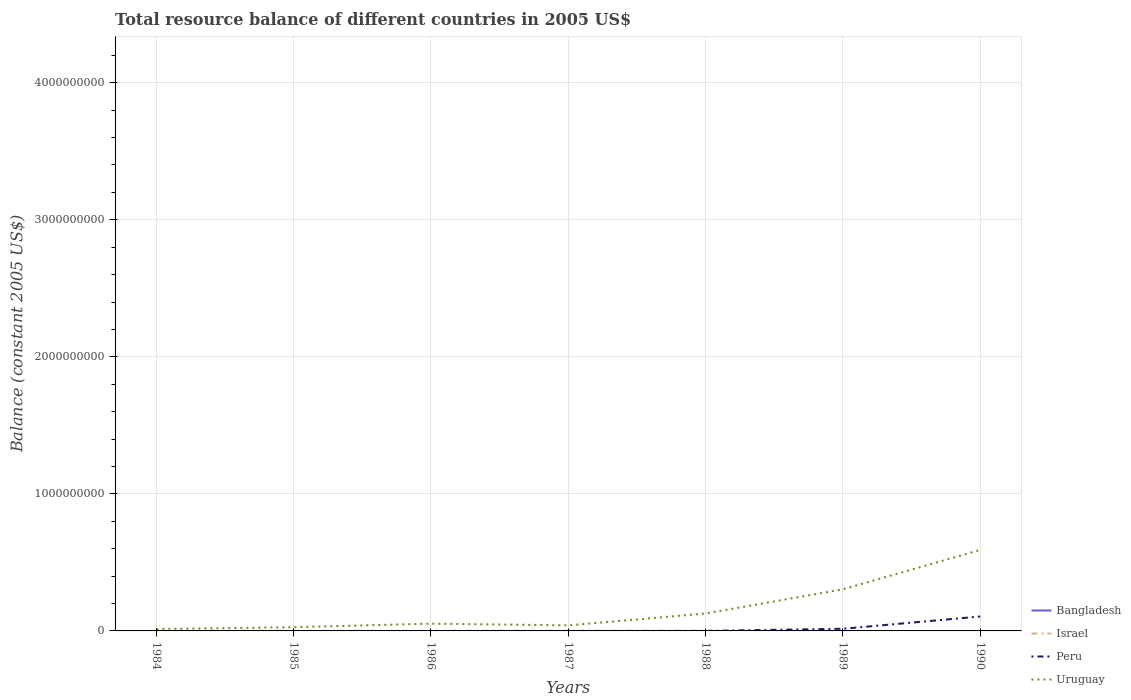Does the line corresponding to Peru intersect with the line corresponding to Israel?
Provide a succinct answer. No. Across all years, what is the maximum total resource balance in Uruguay?
Make the answer very short. 1.41e+07. What is the total total resource balance in Peru in the graph?
Make the answer very short. -1.05e+08. What is the difference between the highest and the second highest total resource balance in Uruguay?
Give a very brief answer. 5.77e+08. What is the difference between the highest and the lowest total resource balance in Israel?
Your answer should be very brief. 0. How many lines are there?
Your answer should be very brief. 2. What is the difference between two consecutive major ticks on the Y-axis?
Make the answer very short. 1.00e+09. Are the values on the major ticks of Y-axis written in scientific E-notation?
Your response must be concise. No. Does the graph contain grids?
Your answer should be compact. Yes. Where does the legend appear in the graph?
Make the answer very short. Bottom right. How are the legend labels stacked?
Offer a terse response. Vertical. What is the title of the graph?
Ensure brevity in your answer.  Total resource balance of different countries in 2005 US$. Does "Iran" appear as one of the legend labels in the graph?
Keep it short and to the point. No. What is the label or title of the Y-axis?
Offer a terse response. Balance (constant 2005 US$). What is the Balance (constant 2005 US$) in Israel in 1984?
Provide a succinct answer. 0. What is the Balance (constant 2005 US$) in Peru in 1984?
Your answer should be very brief. 1.37e+04. What is the Balance (constant 2005 US$) of Uruguay in 1984?
Ensure brevity in your answer.  1.41e+07. What is the Balance (constant 2005 US$) of Bangladesh in 1985?
Keep it short and to the point. 0. What is the Balance (constant 2005 US$) in Israel in 1985?
Provide a short and direct response. 0. What is the Balance (constant 2005 US$) in Peru in 1985?
Your answer should be very brief. 4.43e+04. What is the Balance (constant 2005 US$) of Uruguay in 1985?
Give a very brief answer. 2.71e+07. What is the Balance (constant 2005 US$) in Israel in 1986?
Your response must be concise. 0. What is the Balance (constant 2005 US$) of Peru in 1986?
Your response must be concise. 5.03e+04. What is the Balance (constant 2005 US$) of Uruguay in 1986?
Your answer should be very brief. 5.30e+07. What is the Balance (constant 2005 US$) of Israel in 1987?
Offer a terse response. 0. What is the Balance (constant 2005 US$) in Peru in 1987?
Provide a succinct answer. 7.97e+04. What is the Balance (constant 2005 US$) of Uruguay in 1987?
Your answer should be compact. 4.06e+07. What is the Balance (constant 2005 US$) of Bangladesh in 1988?
Give a very brief answer. 0. What is the Balance (constant 2005 US$) of Israel in 1988?
Make the answer very short. 0. What is the Balance (constant 2005 US$) in Peru in 1988?
Your response must be concise. 5.85e+05. What is the Balance (constant 2005 US$) in Uruguay in 1988?
Your answer should be compact. 1.27e+08. What is the Balance (constant 2005 US$) in Bangladesh in 1989?
Offer a terse response. 0. What is the Balance (constant 2005 US$) of Israel in 1989?
Your answer should be very brief. 0. What is the Balance (constant 2005 US$) in Peru in 1989?
Ensure brevity in your answer.  1.57e+07. What is the Balance (constant 2005 US$) of Uruguay in 1989?
Keep it short and to the point. 3.04e+08. What is the Balance (constant 2005 US$) of Bangladesh in 1990?
Your answer should be very brief. 0. What is the Balance (constant 2005 US$) in Israel in 1990?
Your answer should be very brief. 0. What is the Balance (constant 2005 US$) in Peru in 1990?
Your answer should be compact. 1.05e+08. What is the Balance (constant 2005 US$) of Uruguay in 1990?
Give a very brief answer. 5.91e+08. Across all years, what is the maximum Balance (constant 2005 US$) of Peru?
Your answer should be compact. 1.05e+08. Across all years, what is the maximum Balance (constant 2005 US$) of Uruguay?
Your answer should be compact. 5.91e+08. Across all years, what is the minimum Balance (constant 2005 US$) of Peru?
Offer a terse response. 1.37e+04. Across all years, what is the minimum Balance (constant 2005 US$) in Uruguay?
Provide a short and direct response. 1.41e+07. What is the total Balance (constant 2005 US$) in Bangladesh in the graph?
Give a very brief answer. 0. What is the total Balance (constant 2005 US$) of Israel in the graph?
Ensure brevity in your answer.  0. What is the total Balance (constant 2005 US$) of Peru in the graph?
Your response must be concise. 1.22e+08. What is the total Balance (constant 2005 US$) of Uruguay in the graph?
Your response must be concise. 1.16e+09. What is the difference between the Balance (constant 2005 US$) in Peru in 1984 and that in 1985?
Your response must be concise. -3.06e+04. What is the difference between the Balance (constant 2005 US$) in Uruguay in 1984 and that in 1985?
Your answer should be compact. -1.30e+07. What is the difference between the Balance (constant 2005 US$) in Peru in 1984 and that in 1986?
Give a very brief answer. -3.66e+04. What is the difference between the Balance (constant 2005 US$) of Uruguay in 1984 and that in 1986?
Ensure brevity in your answer.  -3.88e+07. What is the difference between the Balance (constant 2005 US$) of Peru in 1984 and that in 1987?
Offer a very short reply. -6.60e+04. What is the difference between the Balance (constant 2005 US$) of Uruguay in 1984 and that in 1987?
Provide a succinct answer. -2.65e+07. What is the difference between the Balance (constant 2005 US$) in Peru in 1984 and that in 1988?
Your response must be concise. -5.71e+05. What is the difference between the Balance (constant 2005 US$) of Uruguay in 1984 and that in 1988?
Provide a succinct answer. -1.13e+08. What is the difference between the Balance (constant 2005 US$) of Peru in 1984 and that in 1989?
Offer a very short reply. -1.57e+07. What is the difference between the Balance (constant 2005 US$) of Uruguay in 1984 and that in 1989?
Provide a succinct answer. -2.90e+08. What is the difference between the Balance (constant 2005 US$) in Peru in 1984 and that in 1990?
Offer a very short reply. -1.05e+08. What is the difference between the Balance (constant 2005 US$) in Uruguay in 1984 and that in 1990?
Ensure brevity in your answer.  -5.77e+08. What is the difference between the Balance (constant 2005 US$) of Peru in 1985 and that in 1986?
Ensure brevity in your answer.  -6000. What is the difference between the Balance (constant 2005 US$) of Uruguay in 1985 and that in 1986?
Give a very brief answer. -2.59e+07. What is the difference between the Balance (constant 2005 US$) of Peru in 1985 and that in 1987?
Ensure brevity in your answer.  -3.54e+04. What is the difference between the Balance (constant 2005 US$) of Uruguay in 1985 and that in 1987?
Your answer should be compact. -1.35e+07. What is the difference between the Balance (constant 2005 US$) of Peru in 1985 and that in 1988?
Ensure brevity in your answer.  -5.40e+05. What is the difference between the Balance (constant 2005 US$) in Uruguay in 1985 and that in 1988?
Ensure brevity in your answer.  -1.00e+08. What is the difference between the Balance (constant 2005 US$) of Peru in 1985 and that in 1989?
Your answer should be very brief. -1.57e+07. What is the difference between the Balance (constant 2005 US$) in Uruguay in 1985 and that in 1989?
Offer a very short reply. -2.77e+08. What is the difference between the Balance (constant 2005 US$) of Peru in 1985 and that in 1990?
Make the answer very short. -1.05e+08. What is the difference between the Balance (constant 2005 US$) in Uruguay in 1985 and that in 1990?
Make the answer very short. -5.64e+08. What is the difference between the Balance (constant 2005 US$) of Peru in 1986 and that in 1987?
Make the answer very short. -2.94e+04. What is the difference between the Balance (constant 2005 US$) of Uruguay in 1986 and that in 1987?
Give a very brief answer. 1.24e+07. What is the difference between the Balance (constant 2005 US$) of Peru in 1986 and that in 1988?
Your answer should be compact. -5.34e+05. What is the difference between the Balance (constant 2005 US$) in Uruguay in 1986 and that in 1988?
Your answer should be compact. -7.43e+07. What is the difference between the Balance (constant 2005 US$) in Peru in 1986 and that in 1989?
Make the answer very short. -1.57e+07. What is the difference between the Balance (constant 2005 US$) in Uruguay in 1986 and that in 1989?
Offer a very short reply. -2.51e+08. What is the difference between the Balance (constant 2005 US$) of Peru in 1986 and that in 1990?
Your answer should be very brief. -1.05e+08. What is the difference between the Balance (constant 2005 US$) of Uruguay in 1986 and that in 1990?
Your answer should be very brief. -5.38e+08. What is the difference between the Balance (constant 2005 US$) in Peru in 1987 and that in 1988?
Make the answer very short. -5.05e+05. What is the difference between the Balance (constant 2005 US$) of Uruguay in 1987 and that in 1988?
Give a very brief answer. -8.67e+07. What is the difference between the Balance (constant 2005 US$) in Peru in 1987 and that in 1989?
Ensure brevity in your answer.  -1.57e+07. What is the difference between the Balance (constant 2005 US$) of Uruguay in 1987 and that in 1989?
Your response must be concise. -2.63e+08. What is the difference between the Balance (constant 2005 US$) of Peru in 1987 and that in 1990?
Make the answer very short. -1.05e+08. What is the difference between the Balance (constant 2005 US$) in Uruguay in 1987 and that in 1990?
Provide a succinct answer. -5.51e+08. What is the difference between the Balance (constant 2005 US$) of Peru in 1988 and that in 1989?
Ensure brevity in your answer.  -1.52e+07. What is the difference between the Balance (constant 2005 US$) in Uruguay in 1988 and that in 1989?
Give a very brief answer. -1.76e+08. What is the difference between the Balance (constant 2005 US$) in Peru in 1988 and that in 1990?
Your answer should be compact. -1.05e+08. What is the difference between the Balance (constant 2005 US$) of Uruguay in 1988 and that in 1990?
Keep it short and to the point. -4.64e+08. What is the difference between the Balance (constant 2005 US$) in Peru in 1989 and that in 1990?
Make the answer very short. -8.95e+07. What is the difference between the Balance (constant 2005 US$) in Uruguay in 1989 and that in 1990?
Provide a short and direct response. -2.87e+08. What is the difference between the Balance (constant 2005 US$) in Peru in 1984 and the Balance (constant 2005 US$) in Uruguay in 1985?
Your answer should be compact. -2.71e+07. What is the difference between the Balance (constant 2005 US$) in Peru in 1984 and the Balance (constant 2005 US$) in Uruguay in 1986?
Keep it short and to the point. -5.29e+07. What is the difference between the Balance (constant 2005 US$) of Peru in 1984 and the Balance (constant 2005 US$) of Uruguay in 1987?
Keep it short and to the point. -4.06e+07. What is the difference between the Balance (constant 2005 US$) of Peru in 1984 and the Balance (constant 2005 US$) of Uruguay in 1988?
Your answer should be compact. -1.27e+08. What is the difference between the Balance (constant 2005 US$) in Peru in 1984 and the Balance (constant 2005 US$) in Uruguay in 1989?
Offer a terse response. -3.04e+08. What is the difference between the Balance (constant 2005 US$) in Peru in 1984 and the Balance (constant 2005 US$) in Uruguay in 1990?
Provide a short and direct response. -5.91e+08. What is the difference between the Balance (constant 2005 US$) of Peru in 1985 and the Balance (constant 2005 US$) of Uruguay in 1986?
Your answer should be very brief. -5.29e+07. What is the difference between the Balance (constant 2005 US$) in Peru in 1985 and the Balance (constant 2005 US$) in Uruguay in 1987?
Your answer should be compact. -4.05e+07. What is the difference between the Balance (constant 2005 US$) of Peru in 1985 and the Balance (constant 2005 US$) of Uruguay in 1988?
Make the answer very short. -1.27e+08. What is the difference between the Balance (constant 2005 US$) in Peru in 1985 and the Balance (constant 2005 US$) in Uruguay in 1989?
Ensure brevity in your answer.  -3.04e+08. What is the difference between the Balance (constant 2005 US$) of Peru in 1985 and the Balance (constant 2005 US$) of Uruguay in 1990?
Your answer should be very brief. -5.91e+08. What is the difference between the Balance (constant 2005 US$) of Peru in 1986 and the Balance (constant 2005 US$) of Uruguay in 1987?
Your answer should be very brief. -4.05e+07. What is the difference between the Balance (constant 2005 US$) in Peru in 1986 and the Balance (constant 2005 US$) in Uruguay in 1988?
Ensure brevity in your answer.  -1.27e+08. What is the difference between the Balance (constant 2005 US$) of Peru in 1986 and the Balance (constant 2005 US$) of Uruguay in 1989?
Your answer should be very brief. -3.04e+08. What is the difference between the Balance (constant 2005 US$) in Peru in 1986 and the Balance (constant 2005 US$) in Uruguay in 1990?
Keep it short and to the point. -5.91e+08. What is the difference between the Balance (constant 2005 US$) in Peru in 1987 and the Balance (constant 2005 US$) in Uruguay in 1988?
Make the answer very short. -1.27e+08. What is the difference between the Balance (constant 2005 US$) in Peru in 1987 and the Balance (constant 2005 US$) in Uruguay in 1989?
Provide a succinct answer. -3.04e+08. What is the difference between the Balance (constant 2005 US$) of Peru in 1987 and the Balance (constant 2005 US$) of Uruguay in 1990?
Keep it short and to the point. -5.91e+08. What is the difference between the Balance (constant 2005 US$) of Peru in 1988 and the Balance (constant 2005 US$) of Uruguay in 1989?
Provide a succinct answer. -3.03e+08. What is the difference between the Balance (constant 2005 US$) in Peru in 1988 and the Balance (constant 2005 US$) in Uruguay in 1990?
Give a very brief answer. -5.91e+08. What is the difference between the Balance (constant 2005 US$) in Peru in 1989 and the Balance (constant 2005 US$) in Uruguay in 1990?
Provide a succinct answer. -5.75e+08. What is the average Balance (constant 2005 US$) of Bangladesh per year?
Your response must be concise. 0. What is the average Balance (constant 2005 US$) of Peru per year?
Provide a short and direct response. 1.74e+07. What is the average Balance (constant 2005 US$) of Uruguay per year?
Your answer should be compact. 1.65e+08. In the year 1984, what is the difference between the Balance (constant 2005 US$) in Peru and Balance (constant 2005 US$) in Uruguay?
Give a very brief answer. -1.41e+07. In the year 1985, what is the difference between the Balance (constant 2005 US$) in Peru and Balance (constant 2005 US$) in Uruguay?
Offer a terse response. -2.70e+07. In the year 1986, what is the difference between the Balance (constant 2005 US$) in Peru and Balance (constant 2005 US$) in Uruguay?
Give a very brief answer. -5.29e+07. In the year 1987, what is the difference between the Balance (constant 2005 US$) of Peru and Balance (constant 2005 US$) of Uruguay?
Your answer should be compact. -4.05e+07. In the year 1988, what is the difference between the Balance (constant 2005 US$) of Peru and Balance (constant 2005 US$) of Uruguay?
Provide a short and direct response. -1.27e+08. In the year 1989, what is the difference between the Balance (constant 2005 US$) of Peru and Balance (constant 2005 US$) of Uruguay?
Your answer should be very brief. -2.88e+08. In the year 1990, what is the difference between the Balance (constant 2005 US$) of Peru and Balance (constant 2005 US$) of Uruguay?
Provide a short and direct response. -4.86e+08. What is the ratio of the Balance (constant 2005 US$) of Peru in 1984 to that in 1985?
Offer a terse response. 0.31. What is the ratio of the Balance (constant 2005 US$) in Uruguay in 1984 to that in 1985?
Offer a very short reply. 0.52. What is the ratio of the Balance (constant 2005 US$) of Peru in 1984 to that in 1986?
Offer a very short reply. 0.27. What is the ratio of the Balance (constant 2005 US$) of Uruguay in 1984 to that in 1986?
Offer a terse response. 0.27. What is the ratio of the Balance (constant 2005 US$) in Peru in 1984 to that in 1987?
Your answer should be compact. 0.17. What is the ratio of the Balance (constant 2005 US$) of Uruguay in 1984 to that in 1987?
Ensure brevity in your answer.  0.35. What is the ratio of the Balance (constant 2005 US$) of Peru in 1984 to that in 1988?
Ensure brevity in your answer.  0.02. What is the ratio of the Balance (constant 2005 US$) in Uruguay in 1984 to that in 1988?
Ensure brevity in your answer.  0.11. What is the ratio of the Balance (constant 2005 US$) in Peru in 1984 to that in 1989?
Offer a very short reply. 0. What is the ratio of the Balance (constant 2005 US$) of Uruguay in 1984 to that in 1989?
Offer a terse response. 0.05. What is the ratio of the Balance (constant 2005 US$) in Uruguay in 1984 to that in 1990?
Give a very brief answer. 0.02. What is the ratio of the Balance (constant 2005 US$) in Peru in 1985 to that in 1986?
Your answer should be very brief. 0.88. What is the ratio of the Balance (constant 2005 US$) of Uruguay in 1985 to that in 1986?
Your answer should be very brief. 0.51. What is the ratio of the Balance (constant 2005 US$) in Peru in 1985 to that in 1987?
Your answer should be compact. 0.56. What is the ratio of the Balance (constant 2005 US$) of Uruguay in 1985 to that in 1987?
Your answer should be compact. 0.67. What is the ratio of the Balance (constant 2005 US$) in Peru in 1985 to that in 1988?
Ensure brevity in your answer.  0.08. What is the ratio of the Balance (constant 2005 US$) of Uruguay in 1985 to that in 1988?
Your response must be concise. 0.21. What is the ratio of the Balance (constant 2005 US$) in Peru in 1985 to that in 1989?
Provide a short and direct response. 0. What is the ratio of the Balance (constant 2005 US$) of Uruguay in 1985 to that in 1989?
Provide a short and direct response. 0.09. What is the ratio of the Balance (constant 2005 US$) of Uruguay in 1985 to that in 1990?
Your response must be concise. 0.05. What is the ratio of the Balance (constant 2005 US$) of Peru in 1986 to that in 1987?
Provide a succinct answer. 0.63. What is the ratio of the Balance (constant 2005 US$) of Uruguay in 1986 to that in 1987?
Offer a terse response. 1.3. What is the ratio of the Balance (constant 2005 US$) of Peru in 1986 to that in 1988?
Your response must be concise. 0.09. What is the ratio of the Balance (constant 2005 US$) of Uruguay in 1986 to that in 1988?
Keep it short and to the point. 0.42. What is the ratio of the Balance (constant 2005 US$) of Peru in 1986 to that in 1989?
Give a very brief answer. 0. What is the ratio of the Balance (constant 2005 US$) in Uruguay in 1986 to that in 1989?
Offer a terse response. 0.17. What is the ratio of the Balance (constant 2005 US$) in Uruguay in 1986 to that in 1990?
Your response must be concise. 0.09. What is the ratio of the Balance (constant 2005 US$) of Peru in 1987 to that in 1988?
Give a very brief answer. 0.14. What is the ratio of the Balance (constant 2005 US$) in Uruguay in 1987 to that in 1988?
Offer a very short reply. 0.32. What is the ratio of the Balance (constant 2005 US$) of Peru in 1987 to that in 1989?
Ensure brevity in your answer.  0.01. What is the ratio of the Balance (constant 2005 US$) of Uruguay in 1987 to that in 1989?
Make the answer very short. 0.13. What is the ratio of the Balance (constant 2005 US$) of Peru in 1987 to that in 1990?
Make the answer very short. 0. What is the ratio of the Balance (constant 2005 US$) of Uruguay in 1987 to that in 1990?
Keep it short and to the point. 0.07. What is the ratio of the Balance (constant 2005 US$) of Peru in 1988 to that in 1989?
Your answer should be compact. 0.04. What is the ratio of the Balance (constant 2005 US$) of Uruguay in 1988 to that in 1989?
Ensure brevity in your answer.  0.42. What is the ratio of the Balance (constant 2005 US$) in Peru in 1988 to that in 1990?
Give a very brief answer. 0.01. What is the ratio of the Balance (constant 2005 US$) in Uruguay in 1988 to that in 1990?
Your answer should be very brief. 0.22. What is the ratio of the Balance (constant 2005 US$) in Peru in 1989 to that in 1990?
Your response must be concise. 0.15. What is the ratio of the Balance (constant 2005 US$) in Uruguay in 1989 to that in 1990?
Your response must be concise. 0.51. What is the difference between the highest and the second highest Balance (constant 2005 US$) of Peru?
Your answer should be very brief. 8.95e+07. What is the difference between the highest and the second highest Balance (constant 2005 US$) of Uruguay?
Your answer should be very brief. 2.87e+08. What is the difference between the highest and the lowest Balance (constant 2005 US$) of Peru?
Keep it short and to the point. 1.05e+08. What is the difference between the highest and the lowest Balance (constant 2005 US$) in Uruguay?
Give a very brief answer. 5.77e+08. 